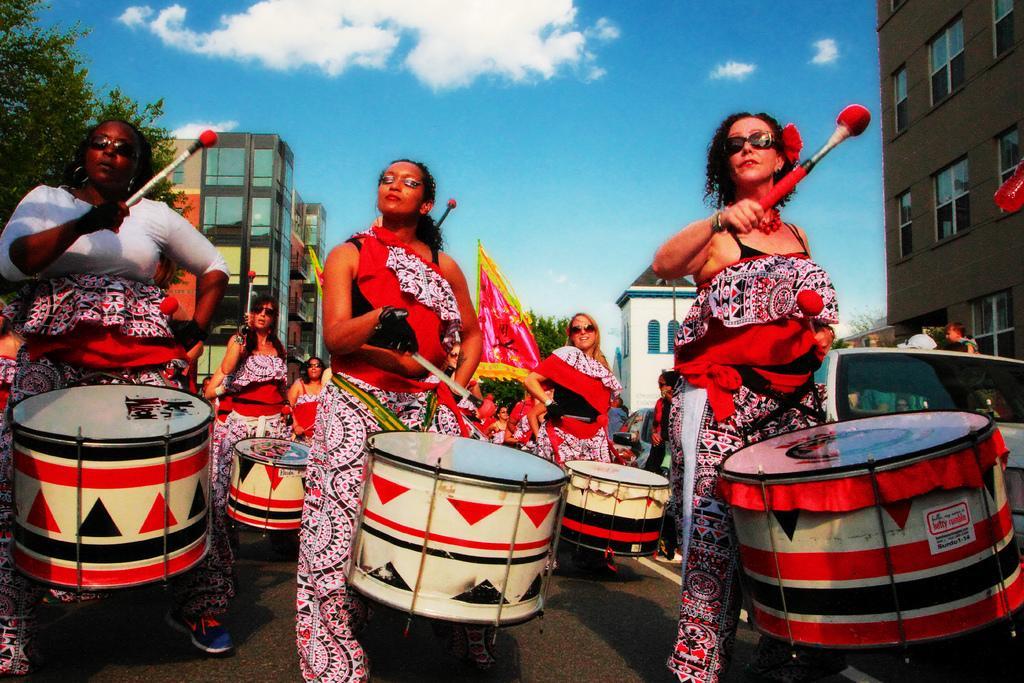Can you describe this image briefly? There are group of women playing drums and there are buildings on the either side of the road. 